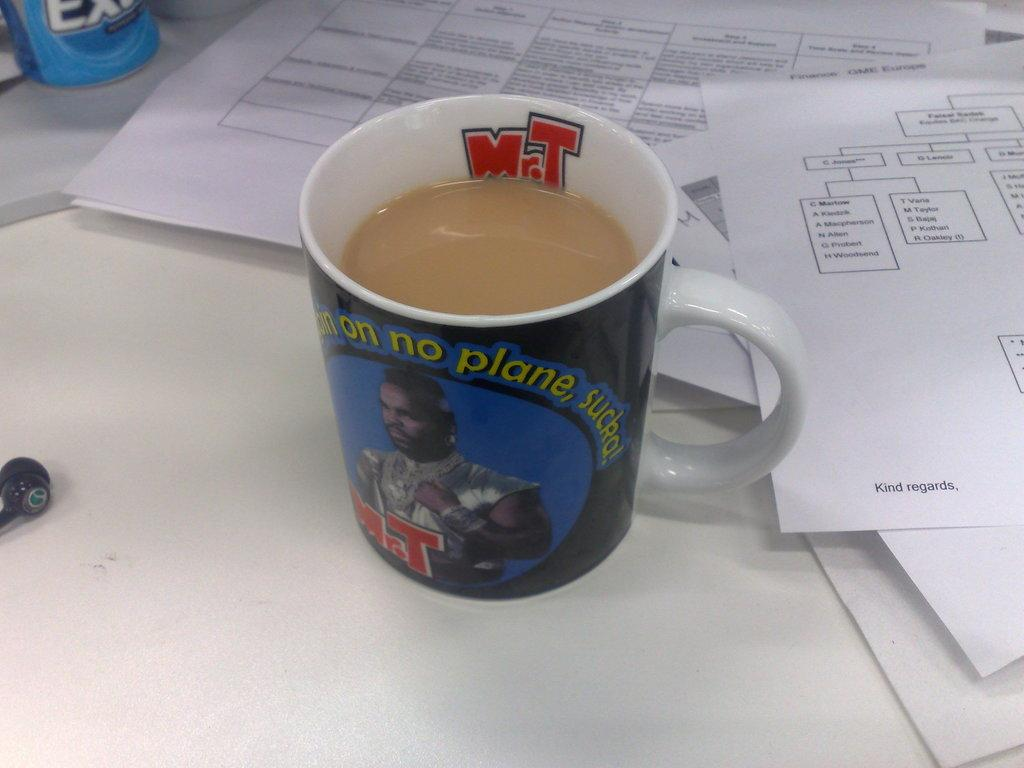<image>
Present a compact description of the photo's key features. A functional coffee mug doubles as a vintage piece of Mr. T memorabilia. 